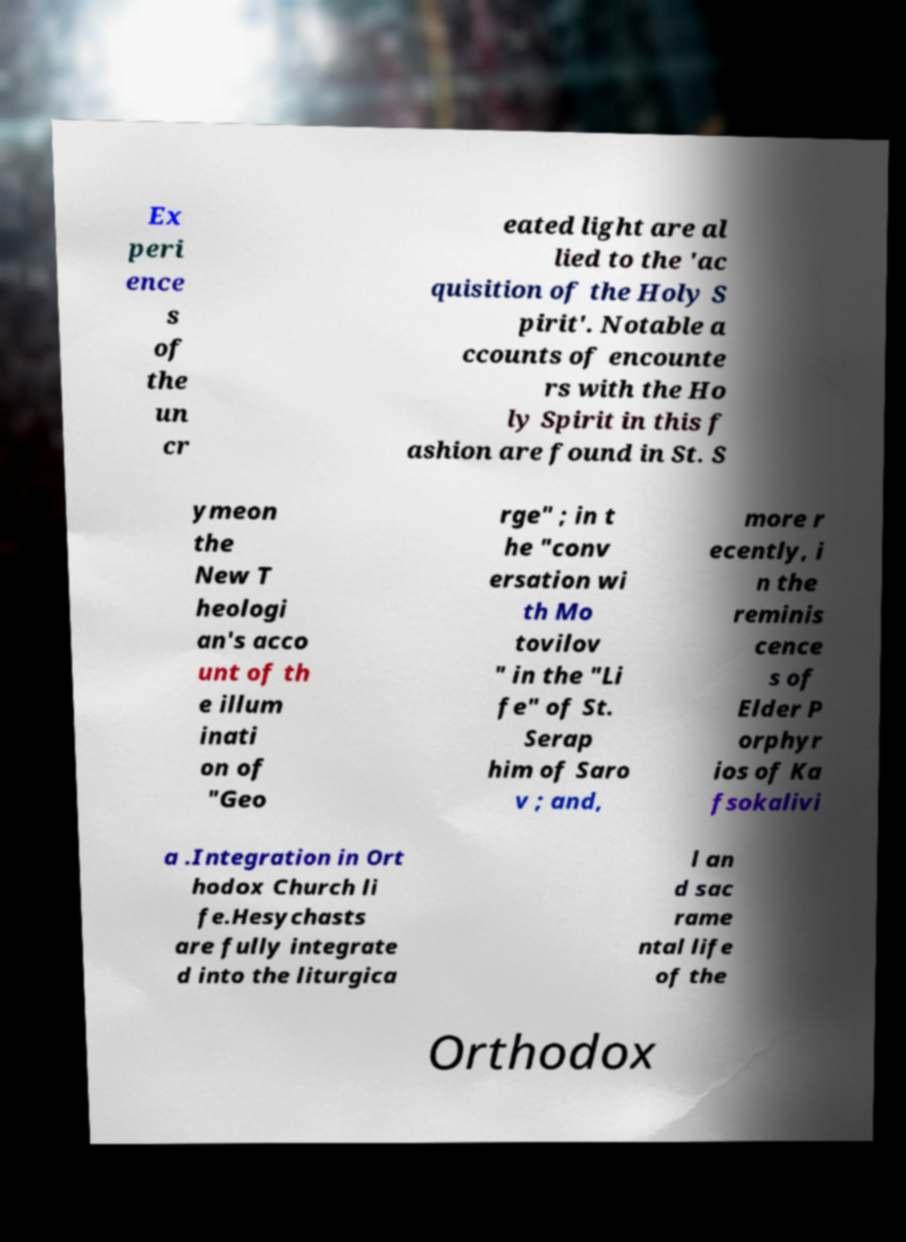Can you read and provide the text displayed in the image?This photo seems to have some interesting text. Can you extract and type it out for me? Ex peri ence s of the un cr eated light are al lied to the 'ac quisition of the Holy S pirit'. Notable a ccounts of encounte rs with the Ho ly Spirit in this f ashion are found in St. S ymeon the New T heologi an's acco unt of th e illum inati on of "Geo rge" ; in t he "conv ersation wi th Mo tovilov " in the "Li fe" of St. Serap him of Saro v ; and, more r ecently, i n the reminis cence s of Elder P orphyr ios of Ka fsokalivi a .Integration in Ort hodox Church li fe.Hesychasts are fully integrate d into the liturgica l an d sac rame ntal life of the Orthodox 